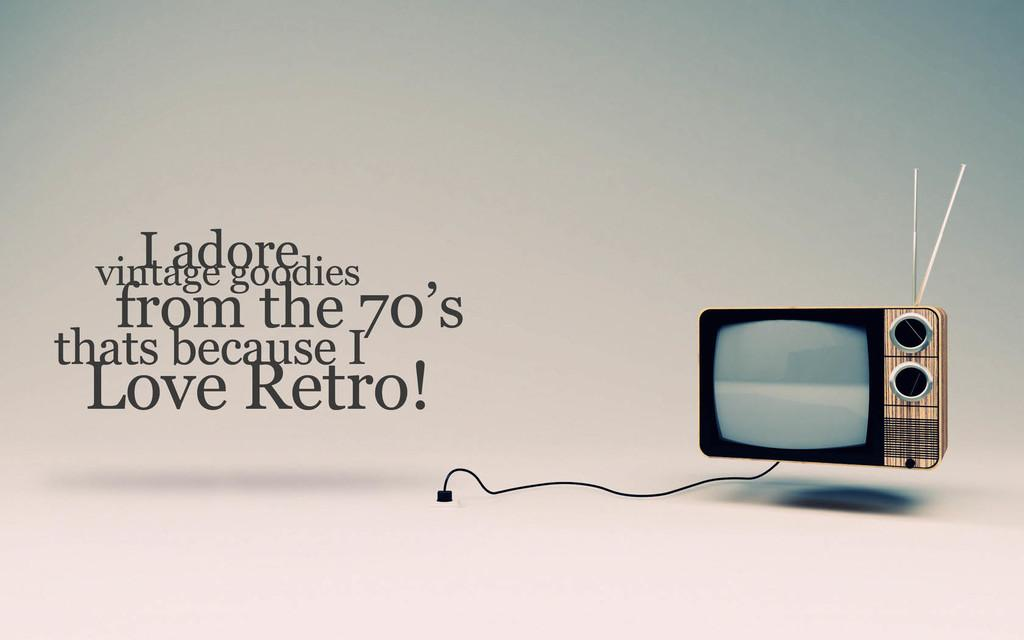Provide a one-sentence caption for the provided image. A retro TV is adored by someone who loves vintage goodies from the 70's. 